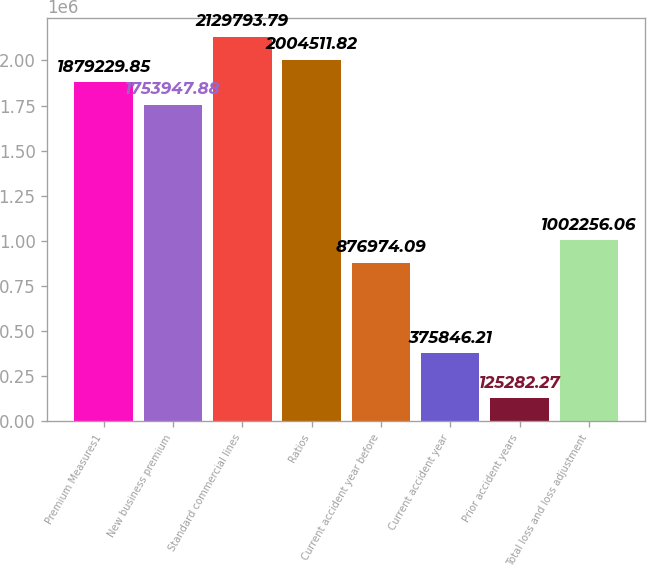Convert chart to OTSL. <chart><loc_0><loc_0><loc_500><loc_500><bar_chart><fcel>Premium Measures1<fcel>New business premium<fcel>Standard commercial lines<fcel>Ratios<fcel>Current accident year before<fcel>Current accident year<fcel>Prior accident years<fcel>Total loss and loss adjustment<nl><fcel>1.87923e+06<fcel>1.75395e+06<fcel>2.12979e+06<fcel>2.00451e+06<fcel>876974<fcel>375846<fcel>125282<fcel>1.00226e+06<nl></chart> 